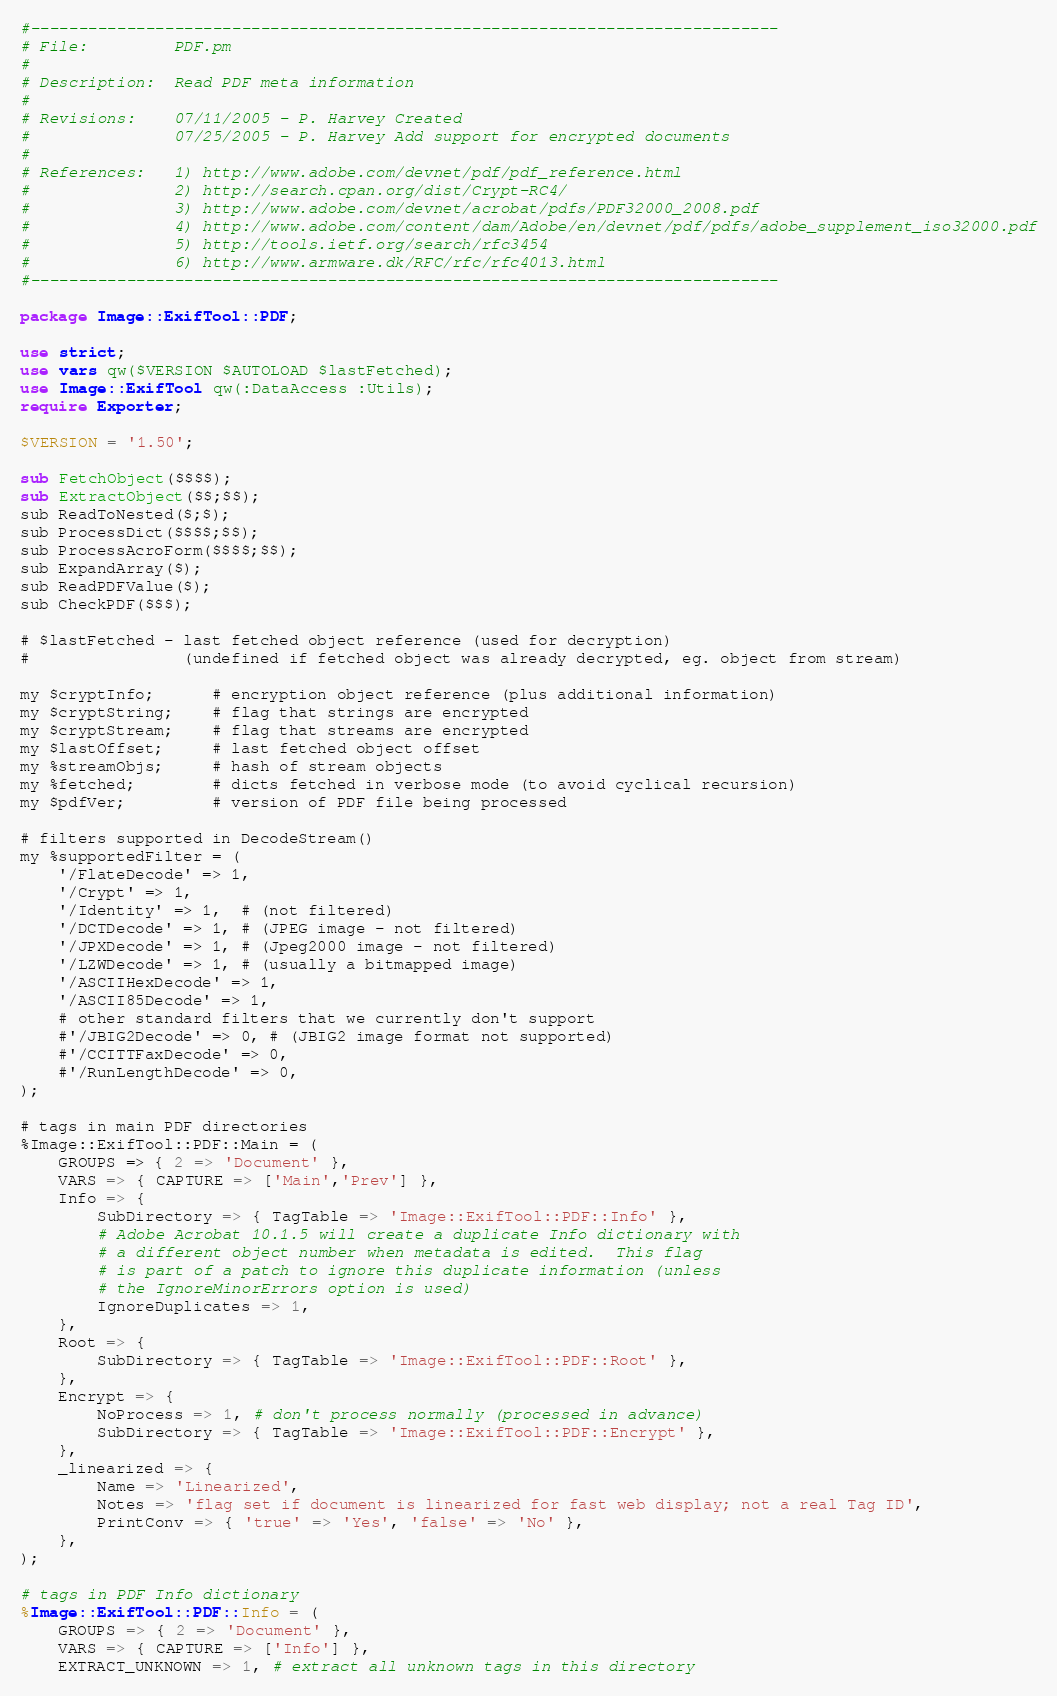<code> <loc_0><loc_0><loc_500><loc_500><_Perl_>#------------------------------------------------------------------------------
# File:         PDF.pm
#
# Description:  Read PDF meta information
#
# Revisions:    07/11/2005 - P. Harvey Created
#               07/25/2005 - P. Harvey Add support for encrypted documents
#
# References:   1) http://www.adobe.com/devnet/pdf/pdf_reference.html
#               2) http://search.cpan.org/dist/Crypt-RC4/
#               3) http://www.adobe.com/devnet/acrobat/pdfs/PDF32000_2008.pdf
#               4) http://www.adobe.com/content/dam/Adobe/en/devnet/pdf/pdfs/adobe_supplement_iso32000.pdf
#               5) http://tools.ietf.org/search/rfc3454
#               6) http://www.armware.dk/RFC/rfc/rfc4013.html
#------------------------------------------------------------------------------

package Image::ExifTool::PDF;

use strict;
use vars qw($VERSION $AUTOLOAD $lastFetched);
use Image::ExifTool qw(:DataAccess :Utils);
require Exporter;

$VERSION = '1.50';

sub FetchObject($$$$);
sub ExtractObject($$;$$);
sub ReadToNested($;$);
sub ProcessDict($$$$;$$);
sub ProcessAcroForm($$$$;$$);
sub ExpandArray($);
sub ReadPDFValue($);
sub CheckPDF($$$);

# $lastFetched - last fetched object reference (used for decryption)
#                (undefined if fetched object was already decrypted, eg. object from stream)

my $cryptInfo;      # encryption object reference (plus additional information)
my $cryptString;    # flag that strings are encrypted
my $cryptStream;    # flag that streams are encrypted
my $lastOffset;     # last fetched object offset
my %streamObjs;     # hash of stream objects
my %fetched;        # dicts fetched in verbose mode (to avoid cyclical recursion)
my $pdfVer;         # version of PDF file being processed

# filters supported in DecodeStream()
my %supportedFilter = (
    '/FlateDecode' => 1,
    '/Crypt' => 1,
    '/Identity' => 1,  # (not filtered)
    '/DCTDecode' => 1, # (JPEG image - not filtered)
    '/JPXDecode' => 1, # (Jpeg2000 image - not filtered)
    '/LZWDecode' => 1, # (usually a bitmapped image)
    '/ASCIIHexDecode' => 1,
    '/ASCII85Decode' => 1,
    # other standard filters that we currently don't support
    #'/JBIG2Decode' => 0, # (JBIG2 image format not supported)
    #'/CCITTFaxDecode' => 0,
    #'/RunLengthDecode' => 0,
);

# tags in main PDF directories
%Image::ExifTool::PDF::Main = (
    GROUPS => { 2 => 'Document' },
    VARS => { CAPTURE => ['Main','Prev'] },
    Info => {
        SubDirectory => { TagTable => 'Image::ExifTool::PDF::Info' },
        # Adobe Acrobat 10.1.5 will create a duplicate Info dictionary with
        # a different object number when metadata is edited.  This flag
        # is part of a patch to ignore this duplicate information (unless
        # the IgnoreMinorErrors option is used)
        IgnoreDuplicates => 1,
    },
    Root => {
        SubDirectory => { TagTable => 'Image::ExifTool::PDF::Root' },
    },
    Encrypt => {
        NoProcess => 1, # don't process normally (processed in advance)
        SubDirectory => { TagTable => 'Image::ExifTool::PDF::Encrypt' },
    },
    _linearized => {
        Name => 'Linearized',
        Notes => 'flag set if document is linearized for fast web display; not a real Tag ID',
        PrintConv => { 'true' => 'Yes', 'false' => 'No' },
    },
);

# tags in PDF Info dictionary
%Image::ExifTool::PDF::Info = (
    GROUPS => { 2 => 'Document' },
    VARS => { CAPTURE => ['Info'] },
    EXTRACT_UNKNOWN => 1, # extract all unknown tags in this directory</code> 